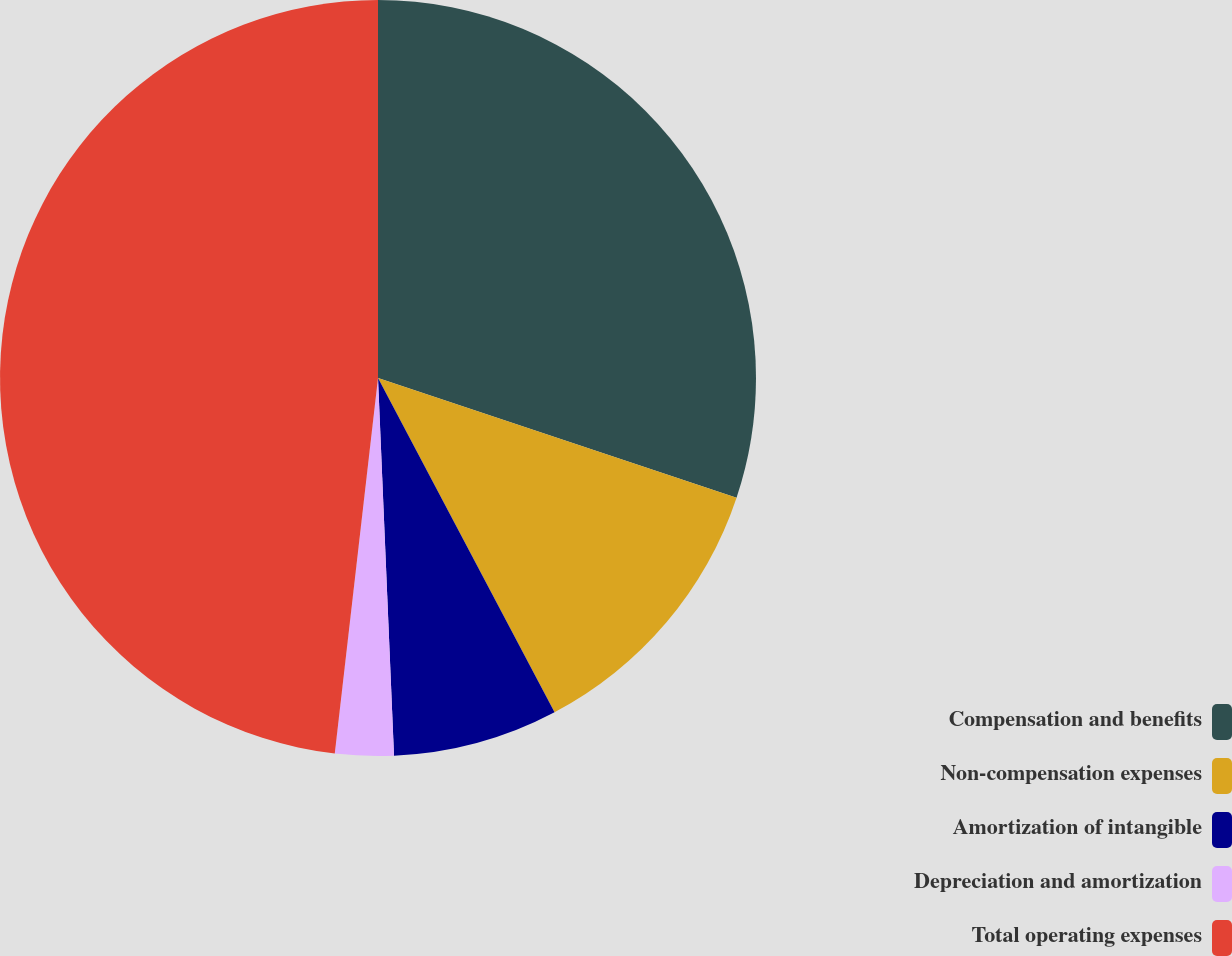Convert chart. <chart><loc_0><loc_0><loc_500><loc_500><pie_chart><fcel>Compensation and benefits<fcel>Non-compensation expenses<fcel>Amortization of intangible<fcel>Depreciation and amortization<fcel>Total operating expenses<nl><fcel>30.13%<fcel>12.14%<fcel>7.06%<fcel>2.5%<fcel>48.18%<nl></chart> 